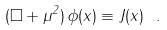Convert formula to latex. <formula><loc_0><loc_0><loc_500><loc_500>( \Box + \mu ^ { 2 } ) \, \phi ( x ) \equiv J ( x ) \ .</formula> 